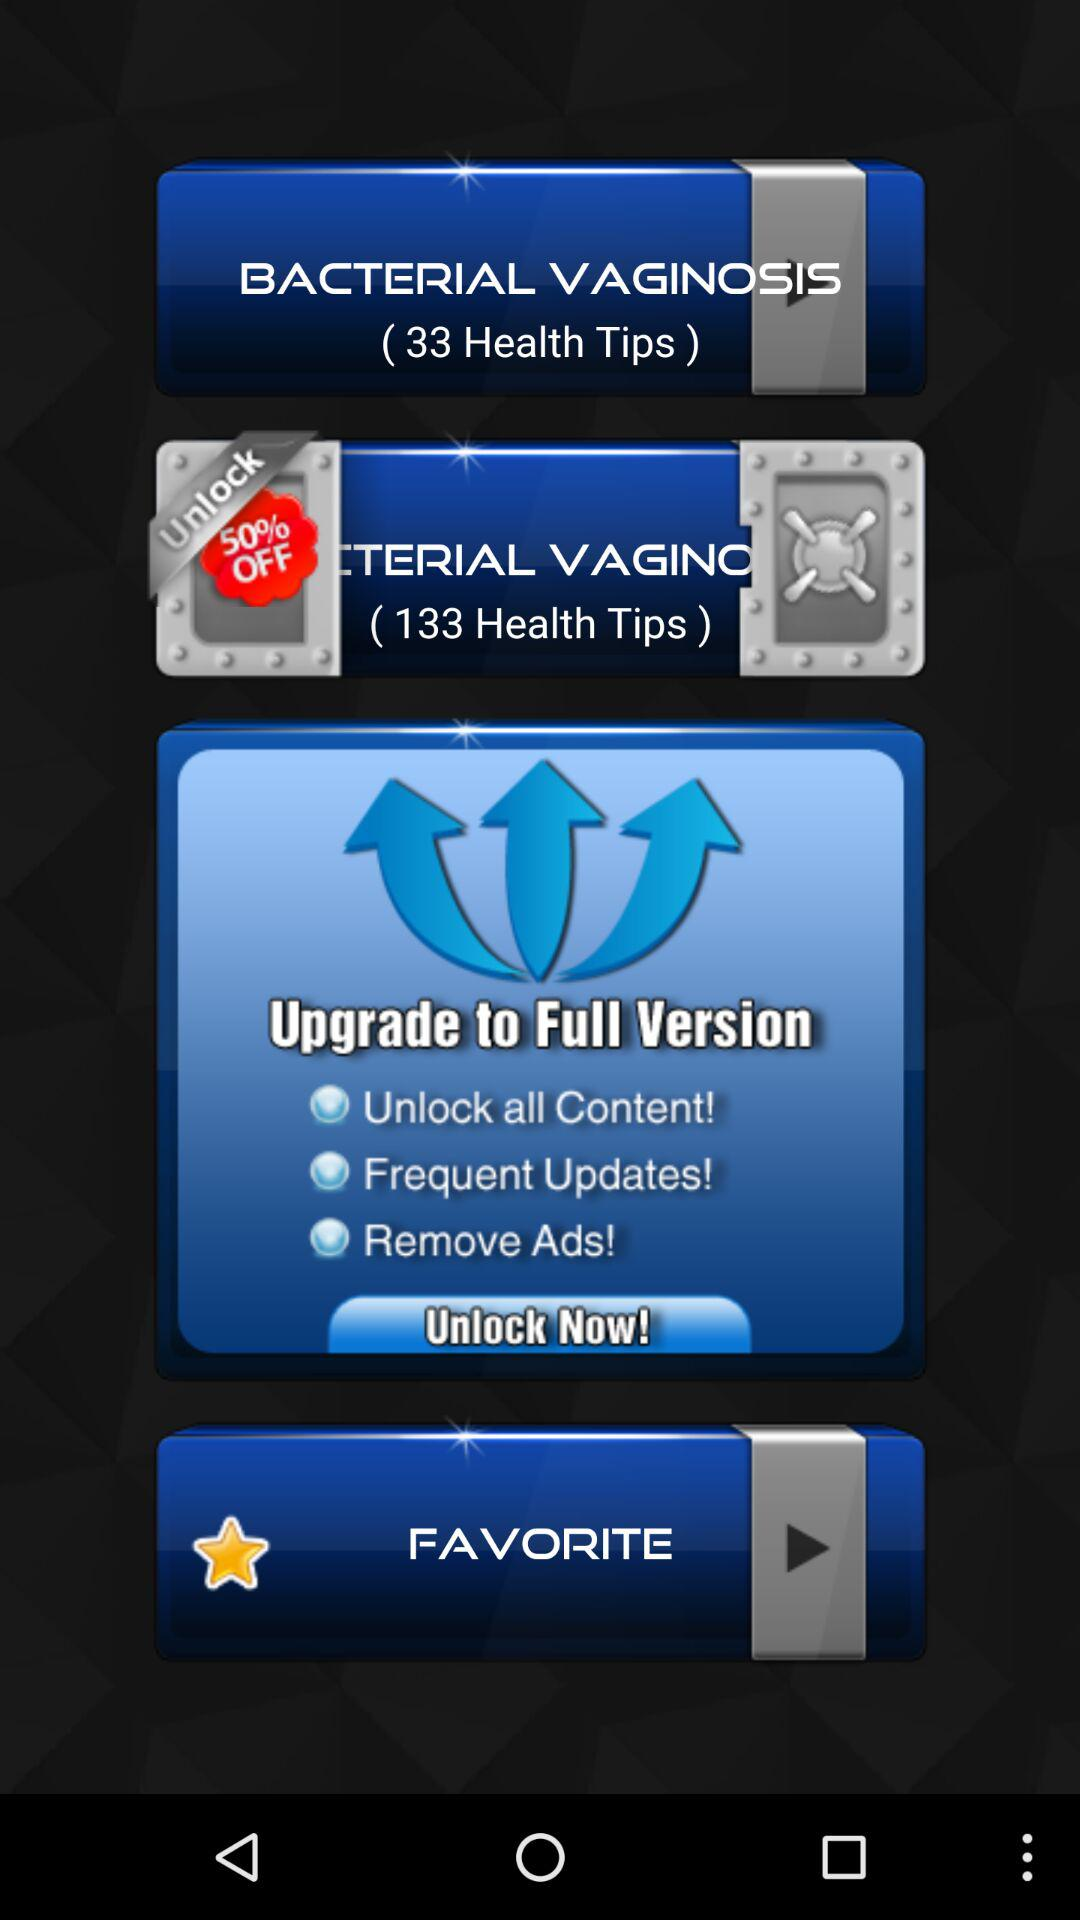What is the discount percentage for bacterial vaginosis? The discount is 50%. 